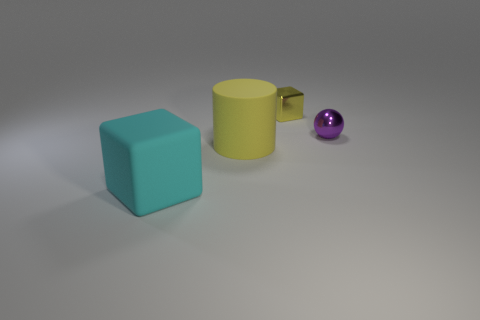There is a thing that is both to the left of the tiny sphere and behind the cylinder; what shape is it?
Offer a very short reply. Cube. How many objects are green objects or metal objects?
Provide a short and direct response. 2. Are any yellow matte things visible?
Provide a succinct answer. Yes. Does the yellow thing that is in front of the shiny cube have the same material as the big cyan object?
Keep it short and to the point. Yes. Are there any other things that have the same shape as the cyan matte object?
Your answer should be compact. Yes. Is the number of cyan matte cubes on the right side of the cyan rubber cube the same as the number of tiny rubber cylinders?
Your answer should be very brief. Yes. What is the material of the cube to the left of the large object that is behind the big matte block?
Offer a terse response. Rubber. What shape is the large cyan matte thing?
Keep it short and to the point. Cube. Are there the same number of big cyan things behind the tiny ball and large cyan blocks that are behind the rubber cylinder?
Ensure brevity in your answer.  Yes. Do the cube that is left of the tiny yellow object and the small thing to the left of the small purple metallic ball have the same color?
Provide a short and direct response. No. 